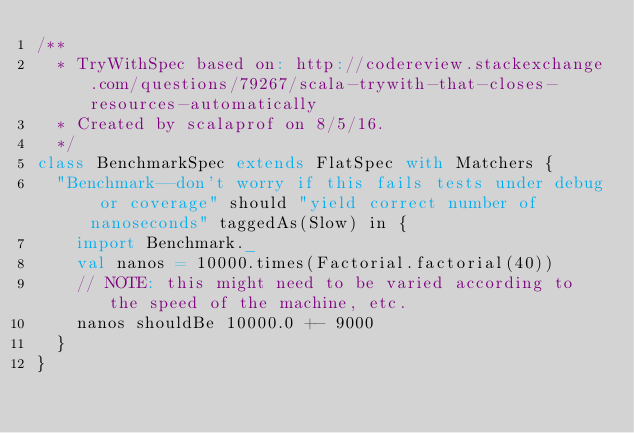<code> <loc_0><loc_0><loc_500><loc_500><_Scala_>/**
  * TryWithSpec based on: http://codereview.stackexchange.com/questions/79267/scala-trywith-that-closes-resources-automatically
  * Created by scalaprof on 8/5/16.
  */
class BenchmarkSpec extends FlatSpec with Matchers {
  "Benchmark--don't worry if this fails tests under debug or coverage" should "yield correct number of nanoseconds" taggedAs(Slow) in {
    import Benchmark._
    val nanos = 10000.times(Factorial.factorial(40))
    // NOTE: this might need to be varied according to the speed of the machine, etc.
    nanos shouldBe 10000.0 +- 9000
  }
}
</code> 